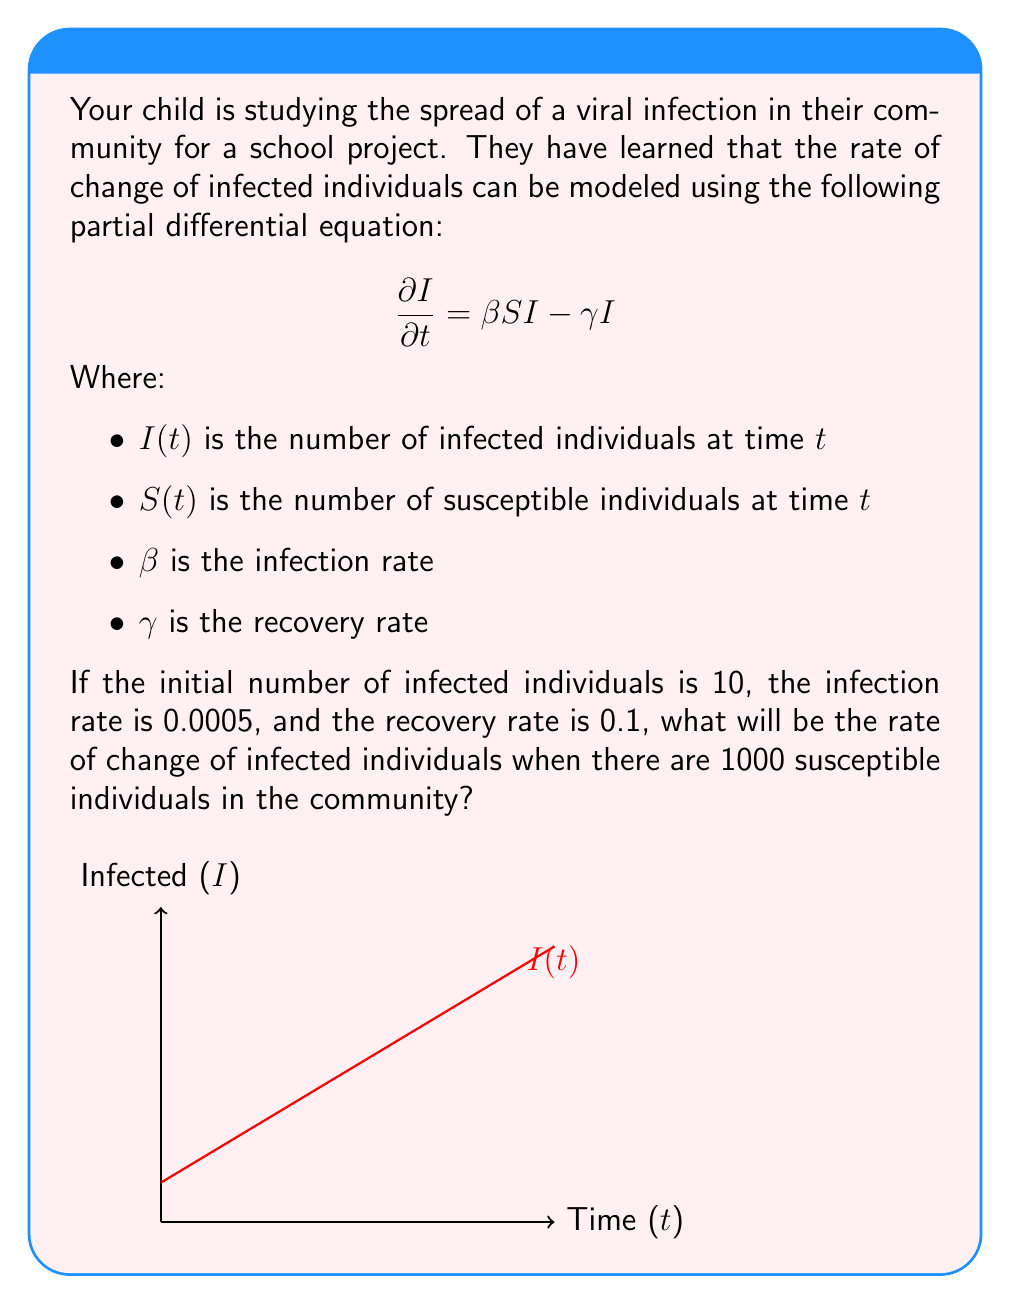Give your solution to this math problem. Let's approach this step-by-step:

1) We are given the partial differential equation:

   $$\frac{\partial I}{\partial t} = \beta SI - \gamma I$$

2) We know the following values:
   - Initial number of infected individuals: $I(0) = 10$
   - Infection rate: $\beta = 0.0005$
   - Recovery rate: $\gamma = 0.1$
   - Number of susceptible individuals: $S = 1000$

3) We need to find $\frac{\partial I}{\partial t}$ at this specific point in time.

4) Let's substitute these values into the equation:

   $$\frac{\partial I}{\partial t} = (0.0005 \times 1000 \times I) - (0.1 \times I)$$

5) Simplify:
   $$\frac{\partial I}{\partial t} = 0.5I - 0.1I = 0.4I$$

6) However, we don't know the current value of $I$. The question doesn't provide this information, so we can't calculate a specific numerical value for $\frac{\partial I}{\partial t}$.

7) Therefore, our final answer will be in terms of $I$.
Answer: $0.4I$ 